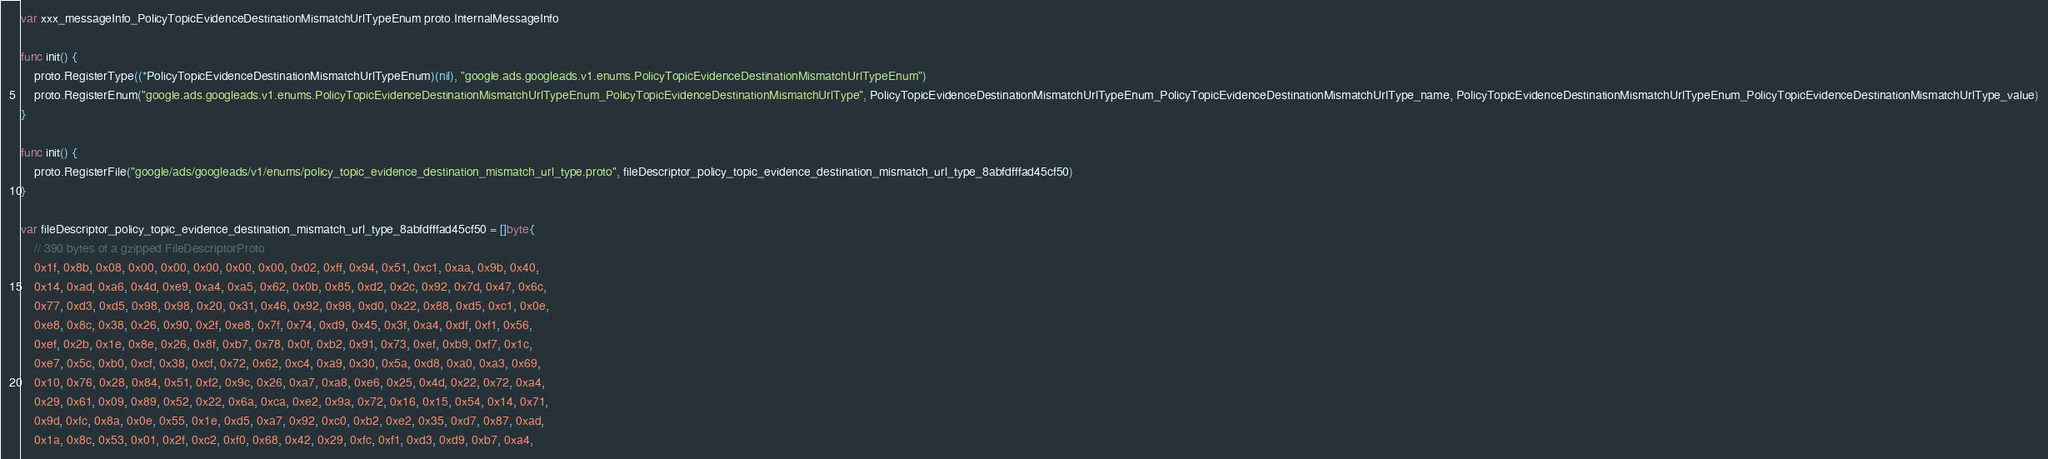Convert code to text. <code><loc_0><loc_0><loc_500><loc_500><_Go_>var xxx_messageInfo_PolicyTopicEvidenceDestinationMismatchUrlTypeEnum proto.InternalMessageInfo

func init() {
	proto.RegisterType((*PolicyTopicEvidenceDestinationMismatchUrlTypeEnum)(nil), "google.ads.googleads.v1.enums.PolicyTopicEvidenceDestinationMismatchUrlTypeEnum")
	proto.RegisterEnum("google.ads.googleads.v1.enums.PolicyTopicEvidenceDestinationMismatchUrlTypeEnum_PolicyTopicEvidenceDestinationMismatchUrlType", PolicyTopicEvidenceDestinationMismatchUrlTypeEnum_PolicyTopicEvidenceDestinationMismatchUrlType_name, PolicyTopicEvidenceDestinationMismatchUrlTypeEnum_PolicyTopicEvidenceDestinationMismatchUrlType_value)
}

func init() {
	proto.RegisterFile("google/ads/googleads/v1/enums/policy_topic_evidence_destination_mismatch_url_type.proto", fileDescriptor_policy_topic_evidence_destination_mismatch_url_type_8abfdfffad45cf50)
}

var fileDescriptor_policy_topic_evidence_destination_mismatch_url_type_8abfdfffad45cf50 = []byte{
	// 390 bytes of a gzipped FileDescriptorProto
	0x1f, 0x8b, 0x08, 0x00, 0x00, 0x00, 0x00, 0x00, 0x02, 0xff, 0x94, 0x51, 0xc1, 0xaa, 0x9b, 0x40,
	0x14, 0xad, 0xa6, 0x4d, 0xe9, 0xa4, 0xa5, 0x62, 0x0b, 0x85, 0xd2, 0x2c, 0x92, 0x7d, 0x47, 0x6c,
	0x77, 0xd3, 0xd5, 0x98, 0x98, 0x20, 0x31, 0x46, 0x92, 0x98, 0xd0, 0x22, 0x88, 0xd5, 0xc1, 0x0e,
	0xe8, 0x8c, 0x38, 0x26, 0x90, 0x2f, 0xe8, 0x7f, 0x74, 0xd9, 0x45, 0x3f, 0xa4, 0xdf, 0xf1, 0x56,
	0xef, 0x2b, 0x1e, 0x8e, 0x26, 0x8f, 0xb7, 0x78, 0x0f, 0xb2, 0x91, 0x73, 0xef, 0xb9, 0xf7, 0x1c,
	0xe7, 0x5c, 0xb0, 0xcf, 0x38, 0xcf, 0x72, 0x62, 0xc4, 0xa9, 0x30, 0x5a, 0xd8, 0xa0, 0xa3, 0x69,
	0x10, 0x76, 0x28, 0x84, 0x51, 0xf2, 0x9c, 0x26, 0xa7, 0xa8, 0xe6, 0x25, 0x4d, 0x22, 0x72, 0xa4,
	0x29, 0x61, 0x09, 0x89, 0x52, 0x22, 0x6a, 0xca, 0xe2, 0x9a, 0x72, 0x16, 0x15, 0x54, 0x14, 0x71,
	0x9d, 0xfc, 0x8a, 0x0e, 0x55, 0x1e, 0xd5, 0xa7, 0x92, 0xc0, 0xb2, 0xe2, 0x35, 0xd7, 0x87, 0xad,
	0x1a, 0x8c, 0x53, 0x01, 0x2f, 0xc2, 0xf0, 0x68, 0x42, 0x29, 0xfc, 0xf1, 0xd3, 0xd9, 0xb7, 0xa4,</code> 